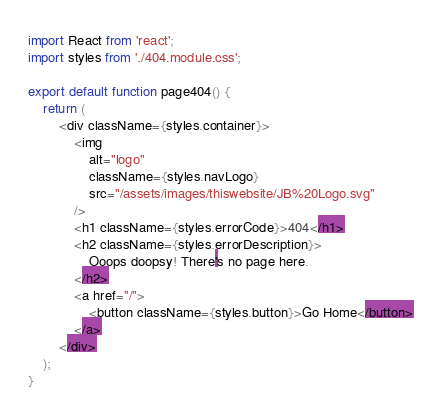Convert code to text. <code><loc_0><loc_0><loc_500><loc_500><_TypeScript_>import React from 'react';
import styles from './404.module.css';

export default function page404() {
    return (
        <div className={styles.container}>
            <img
                alt="logo"
                className={styles.navLogo}
                src="/assets/images/thiswebsite/JB%20Logo.svg"
            />
            <h1 className={styles.errorCode}>404</h1>
            <h2 className={styles.errorDescription}>
                Ooops doopsy! There's no page here.
            </h2>
            <a href="/">
                <button className={styles.button}>Go Home</button>
            </a>
        </div>
    );
}
</code> 